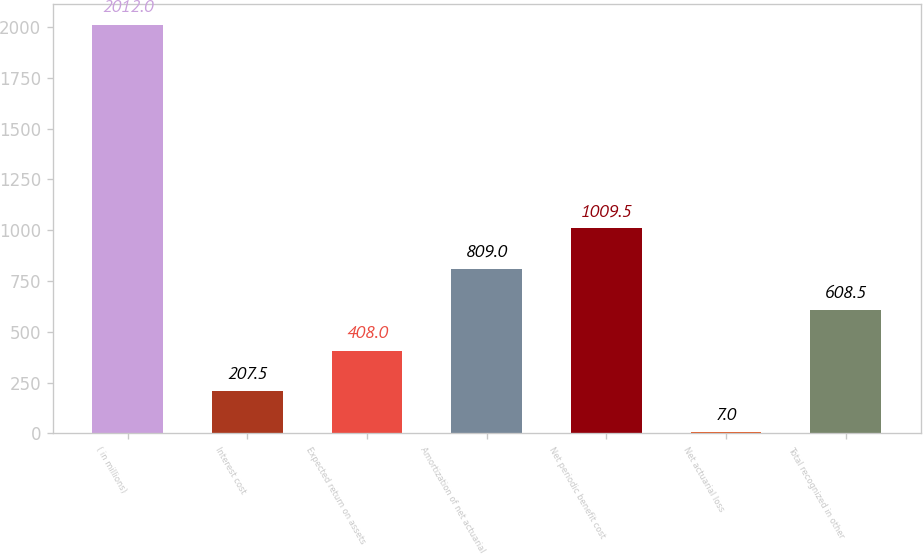Convert chart. <chart><loc_0><loc_0><loc_500><loc_500><bar_chart><fcel>( in millions)<fcel>Interest cost<fcel>Expected return on assets<fcel>Amortization of net actuarial<fcel>Net periodic benefit cost<fcel>Net actuarial loss<fcel>Total recognized in other<nl><fcel>2012<fcel>207.5<fcel>408<fcel>809<fcel>1009.5<fcel>7<fcel>608.5<nl></chart> 